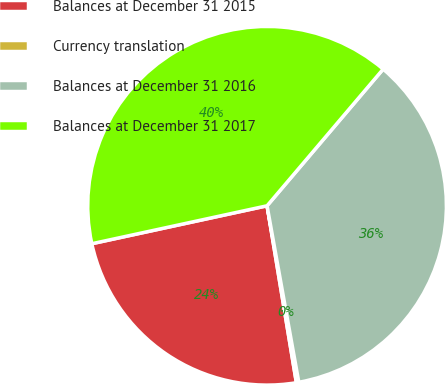Convert chart. <chart><loc_0><loc_0><loc_500><loc_500><pie_chart><fcel>Balances at December 31 2015<fcel>Currency translation<fcel>Balances at December 31 2016<fcel>Balances at December 31 2017<nl><fcel>24.22%<fcel>0.22%<fcel>35.96%<fcel>39.6%<nl></chart> 